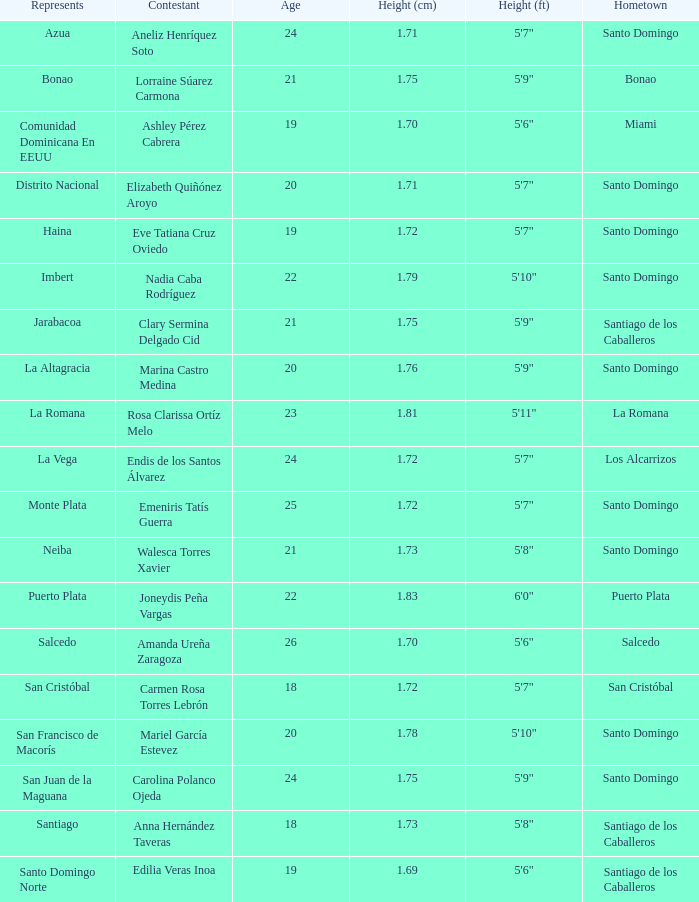Name the represents for 1.76 cm La Altagracia. 